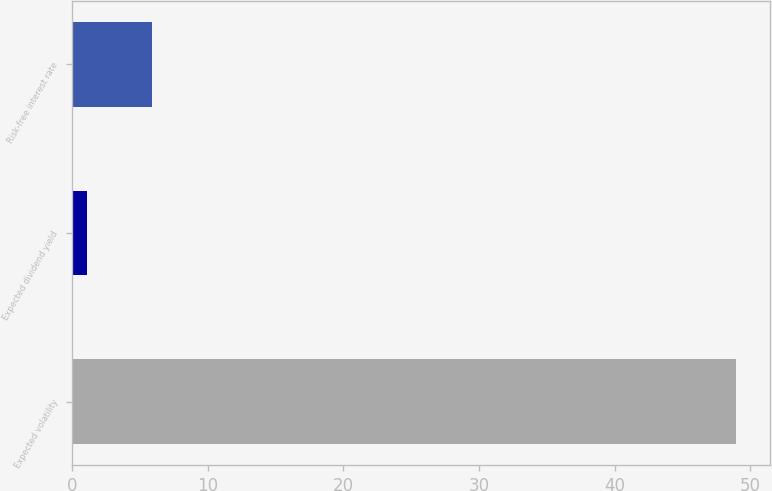Convert chart. <chart><loc_0><loc_0><loc_500><loc_500><bar_chart><fcel>Expected volatility<fcel>Expected dividend yield<fcel>Risk-free interest rate<nl><fcel>48.96<fcel>1.1<fcel>5.89<nl></chart> 